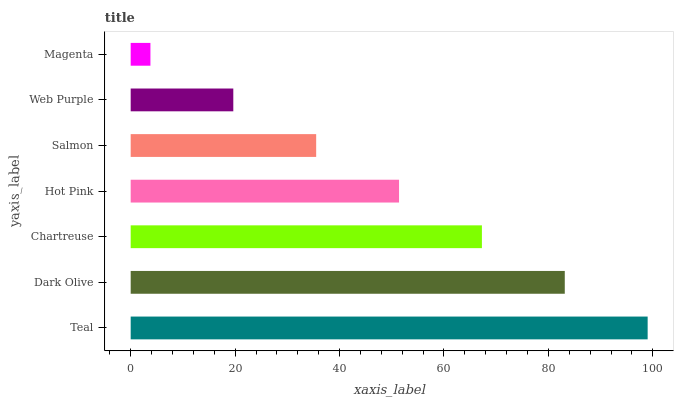Is Magenta the minimum?
Answer yes or no. Yes. Is Teal the maximum?
Answer yes or no. Yes. Is Dark Olive the minimum?
Answer yes or no. No. Is Dark Olive the maximum?
Answer yes or no. No. Is Teal greater than Dark Olive?
Answer yes or no. Yes. Is Dark Olive less than Teal?
Answer yes or no. Yes. Is Dark Olive greater than Teal?
Answer yes or no. No. Is Teal less than Dark Olive?
Answer yes or no. No. Is Hot Pink the high median?
Answer yes or no. Yes. Is Hot Pink the low median?
Answer yes or no. Yes. Is Web Purple the high median?
Answer yes or no. No. Is Magenta the low median?
Answer yes or no. No. 